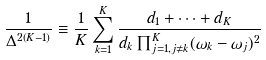<formula> <loc_0><loc_0><loc_500><loc_500>\frac { 1 } { \Delta ^ { 2 ( K - 1 ) } } \equiv \frac { 1 } { K } \sum _ { k = 1 } ^ { K } \frac { d _ { 1 } + \dots + d _ { K } } { d _ { k } \prod _ { j = 1 , j \ne k } ^ { K } ( \omega _ { k } - \omega _ { j } ) ^ { 2 } }</formula> 